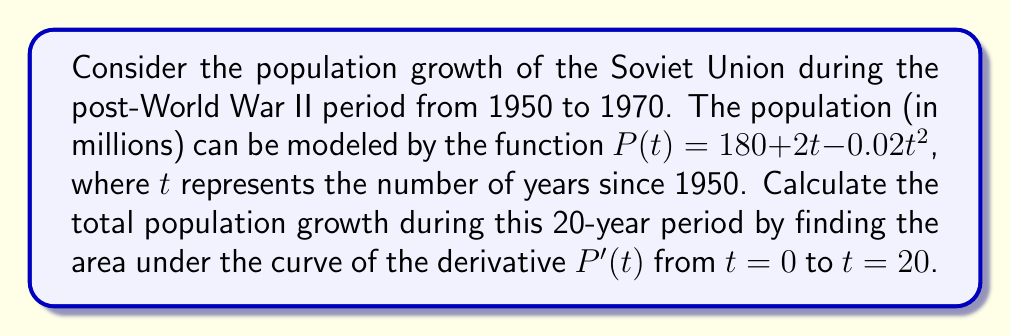Give your solution to this math problem. To solve this problem, we'll follow these steps:

1) First, we need to find the derivative of $P(t)$:
   $$P'(t) = 2 - 0.04t$$

2) The area under the curve of $P'(t)$ from $t=0$ to $t=20$ represents the total population growth. We can find this using a definite integral:
   $$\text{Population Growth} = \int_0^{20} P'(t) dt = \int_0^{20} (2 - 0.04t) dt$$

3) Let's evaluate this integral:
   $$\begin{align}
   \int_0^{20} (2 - 0.04t) dt &= [2t - 0.02t^2]_0^{20} \\
   &= (2(20) - 0.02(20)^2) - (2(0) - 0.02(0)^2) \\
   &= (40 - 8) - 0 \\
   &= 32
   \end{align}$$

4) The result of the integral is 32 million, which represents the total population growth over the 20-year period.

This mathematical approach allows us to analyze population dynamics during a significant period in Soviet history, which could be relevant for discussions about the demographic impacts of post-war policies and economic development in the USSR.
Answer: The total population growth of the Soviet Union from 1950 to 1970, based on the given model, was 32 million people. 